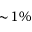Convert formula to latex. <formula><loc_0><loc_0><loc_500><loc_500>\sim \, 1 \%</formula> 